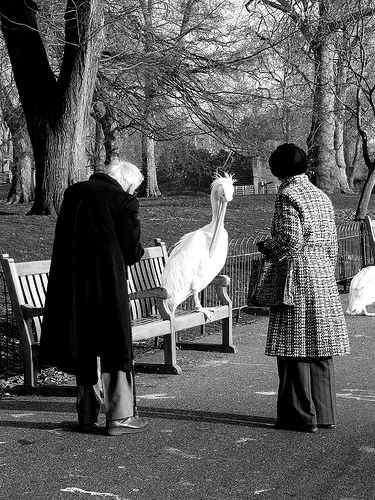Please provide a short description for this region: [0.62, 0.28, 0.82, 0.86]. A woman wearing a patterned coat. 